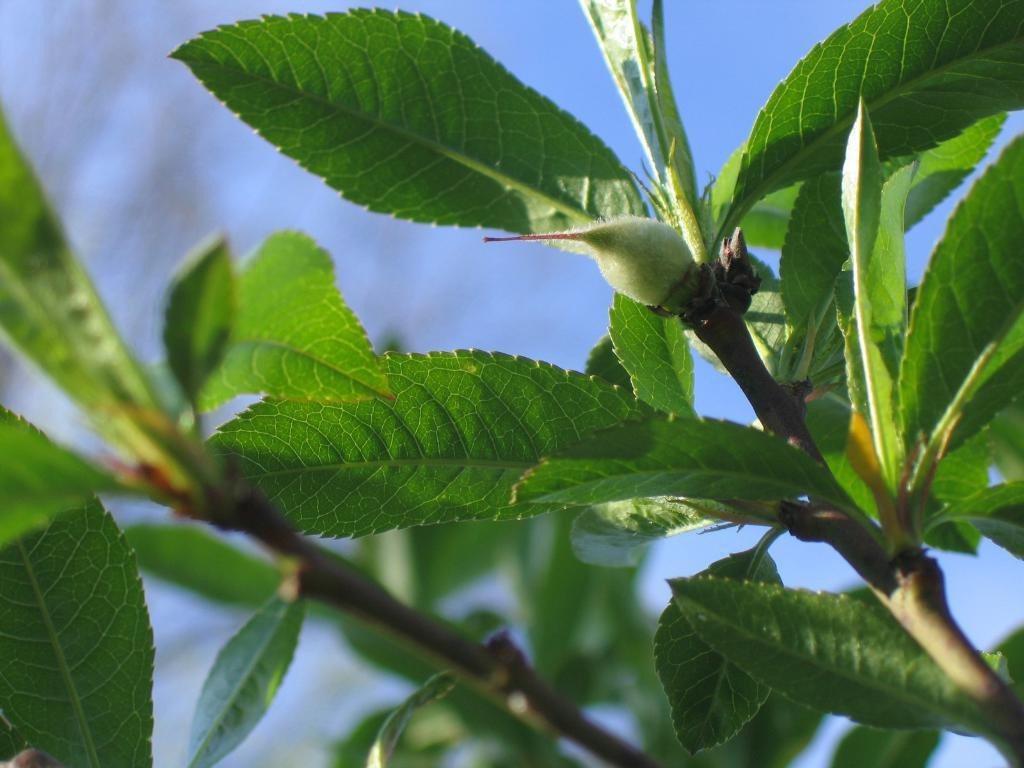What is the main subject of the image? The main subject of the image is two branches of a tree. Can you describe the branches in more detail? Unfortunately, the provided facts do not offer any additional details about the branches. What type of vegetation might these branches belong to? Based on the fact that they are branches, we can infer that they belong to a tree. However, the specific type of tree cannot be determined from the given information. What type of sea creatures can be seen swimming around the branches in the image? There is no sea or sea creatures present in the image; it features two branches of a tree. 